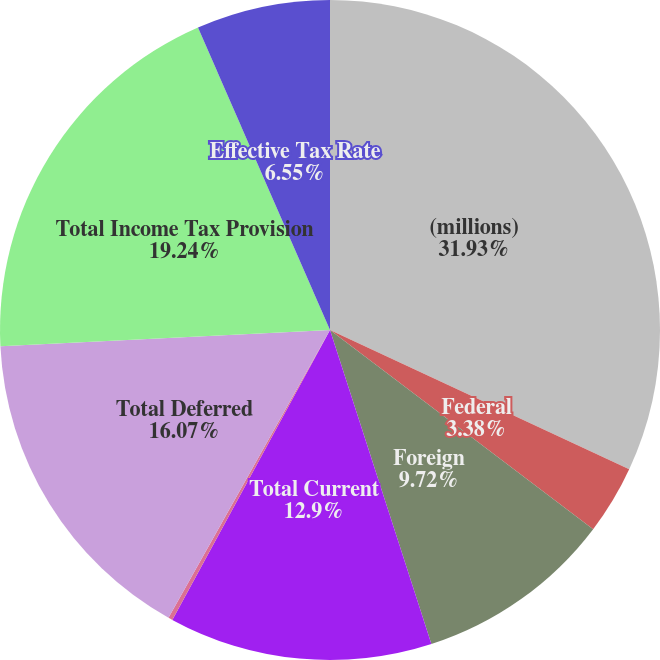<chart> <loc_0><loc_0><loc_500><loc_500><pie_chart><fcel>(millions)<fcel>Federal<fcel>Foreign<fcel>Total Current<fcel>State<fcel>Total Deferred<fcel>Total Income Tax Provision<fcel>Effective Tax Rate<nl><fcel>31.93%<fcel>3.38%<fcel>9.72%<fcel>12.9%<fcel>0.21%<fcel>16.07%<fcel>19.24%<fcel>6.55%<nl></chart> 